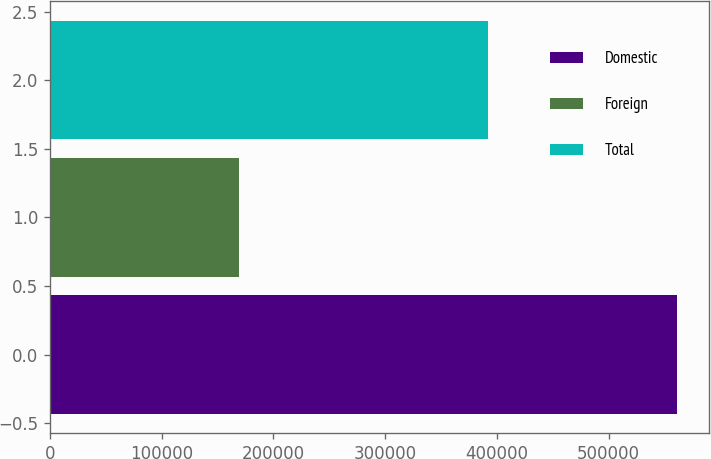Convert chart. <chart><loc_0><loc_0><loc_500><loc_500><bar_chart><fcel>Domestic<fcel>Foreign<fcel>Total<nl><fcel>561409<fcel>169476<fcel>391933<nl></chart> 